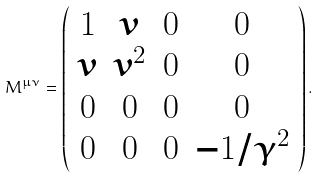<formula> <loc_0><loc_0><loc_500><loc_500>M ^ { \mu \nu } = \left ( \begin{array} { c c c c } 1 & v & 0 & 0 \\ v & v ^ { 2 } & 0 & 0 \\ 0 & 0 & 0 & 0 \\ 0 & 0 & 0 & - 1 / \gamma ^ { 2 } \end{array} \right ) .</formula> 